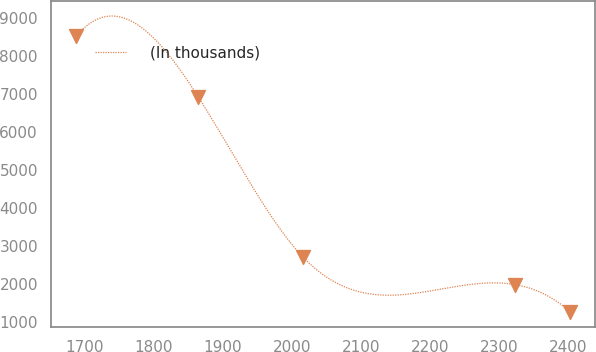<chart> <loc_0><loc_0><loc_500><loc_500><line_chart><ecel><fcel>(In thousands)<nl><fcel>1686.89<fcel>8511.96<nl><fcel>1863.81<fcel>6932.22<nl><fcel>2015.5<fcel>2718.54<nl><fcel>2322.33<fcel>1994.36<nl><fcel>2402.81<fcel>1270.18<nl></chart> 